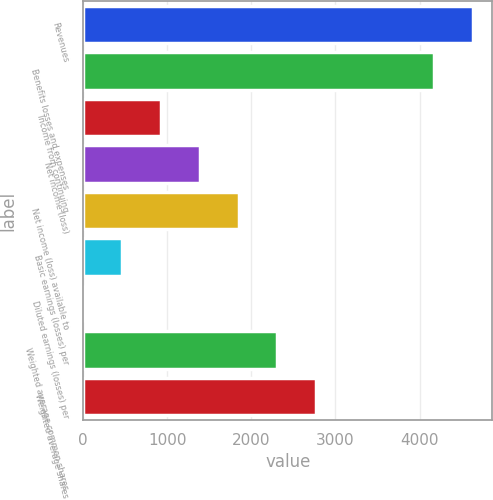Convert chart to OTSL. <chart><loc_0><loc_0><loc_500><loc_500><bar_chart><fcel>Revenues<fcel>Benefits losses and expenses<fcel>Income from continuing<fcel>Net income (loss)<fcel>Net income (loss) available to<fcel>Basic earnings (losses) per<fcel>Diluted earnings (losses) per<fcel>Weighted average common shares<fcel>Weighted average shares<nl><fcel>4634.61<fcel>4173<fcel>924.08<fcel>1385.69<fcel>1847.3<fcel>462.47<fcel>0.86<fcel>2308.91<fcel>2770.52<nl></chart> 